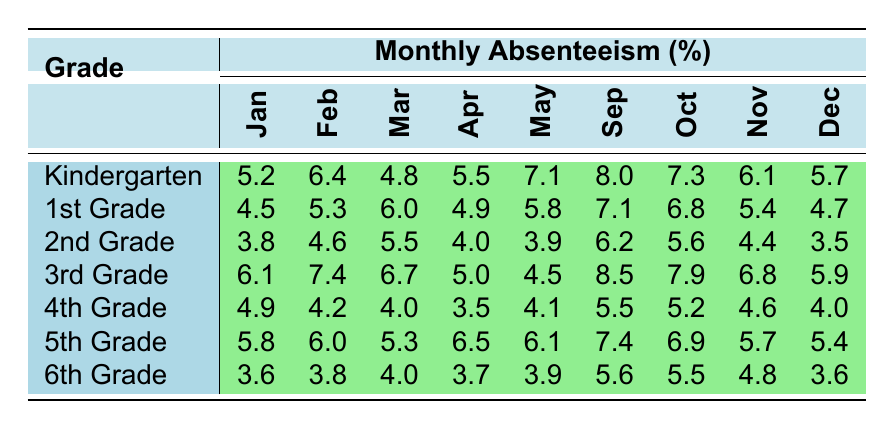What is the absenteeism rate for 2nd Grade in March? The table shows that for 2nd Grade, the absenteeism rate in March is listed as 5.5%.
Answer: 5.5% Which month had the highest absenteeism rate for Kindergarten? Looking at the Kindergarten row, the highest absenteeism rate is in May at 7.1%.
Answer: 7.1% How does 5th Grade's absenteeism rate in April compare to that of 4th Grade in the same month? For April, 5th Grade's rate is 6.5% while 4th Grade's rate is 3.5%. The difference is 6.5% - 3.5% = 3.0%.
Answer: 3.0% What is the average absenteeism rate for 1st Grade across all months? Adding the monthly rates for 1st Grade: (4.5 + 5.3 + 6.0 + 4.9 + 5.8 + 7.1 + 6.8 + 5.4 + 4.7) = 56.6%. There are 9 months, so the average is 56.6% / 9 ≈ 6.29%.
Answer: 6.29% Did 6th Grade have a higher absenteeism rate in October compared to May? In October, 6th Grade had a rate of 5.5% and in May it was 3.9%. Since 5.5% > 3.9%, the statement is true.
Answer: Yes Which grade had the lowest absenteeism rate in December? The table shows the absenteeism rates for December: Kindergarten (5.7%), 1st Grade (4.7%), 2nd Grade (3.5%), 3rd Grade (5.9%), 4th Grade (4.0%), 5th Grade (5.4%), and 6th Grade (3.6%). The lowest is 3.5% for 2nd Grade.
Answer: 2nd Grade What is the total absenteeism rate for 3rd Grade from January to April? Summing the rates for 3rd Grade: January (6.1%) + February (7.4%) + March (6.7%) + April (5.0%) = 25.2%.
Answer: 25.2% How does the average absenteeism rate for 4th Grade compare to that of 5th Grade across the year? For 4th Grade: (4.9 + 4.2 + 4.0 + 3.5 + 4.1 + 5.5 + 5.2 + 4.6 + 4.0) = 43.0%, averaging 43.0 / 9 ≈ 4.78%. For 5th Grade: (5.8 + 6.0 + 5.3 + 6.5 + 6.1 + 7.4 + 6.9 + 5.7 + 5.4) = 54.1%, averaging 54.1 / 9 ≈ 6.01%. Since 4.78% < 6.01%, 4th Grade has a lower average rate.
Answer: 4th Grade is lower Identify the month with the lowest absenteeism rate for any grade. The rates for each month show that 2nd Grade has the lowest rate in December at 3.5%.
Answer: December 